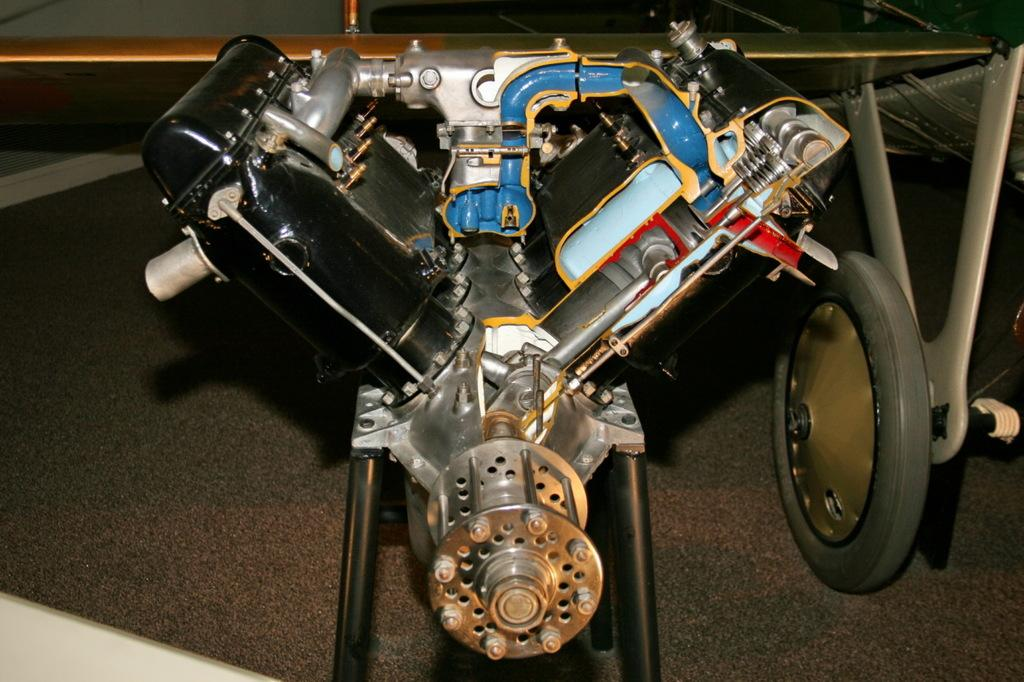What type of machine is present in the image? There is a motor machine in the image. How many arches can be seen supporting the motor machine in the image? There are no arches present in the image; it only features a motor machine. What time of day is depicted in the image, considering the hour? The image does not provide any information about the time of day or the hour, as it only features a motor machine. 